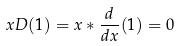<formula> <loc_0><loc_0><loc_500><loc_500>x D ( 1 ) = x * \frac { d } { d x } ( 1 ) = 0</formula> 